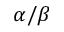<formula> <loc_0><loc_0><loc_500><loc_500>\alpha / \beta</formula> 